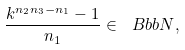Convert formula to latex. <formula><loc_0><loc_0><loc_500><loc_500>\frac { k ^ { n _ { 2 } n _ { 3 } - n _ { 1 } } - 1 } { n _ { 1 } } \in { \ B b b N } ,</formula> 